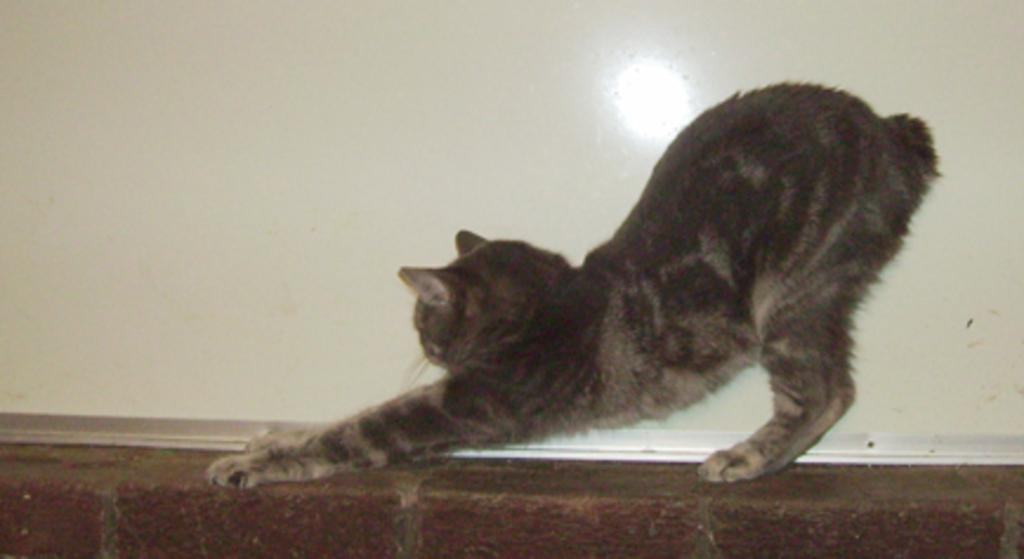What type of animal is in the image? There is a cat in the image. What is the cat doing in the image? The cat is standing on a surface. What can be seen in the background of the image? There is a wall in the background of the image. What type of punishment is the cat receiving in the image? There is no indication in the image that the cat is receiving any punishment. 